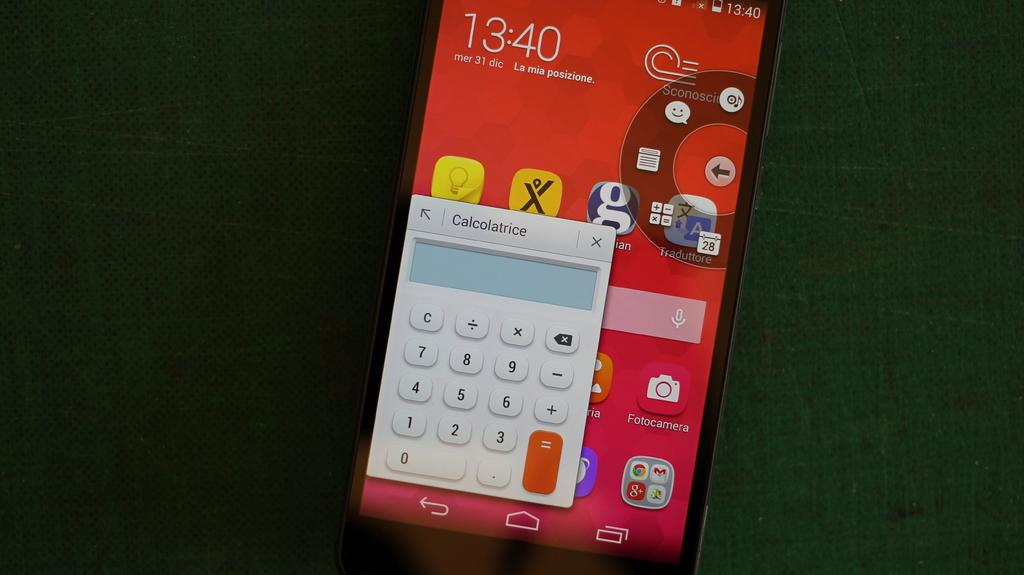<image>
Summarize the visual content of the image. A phone screen with the calculator open and clock showing 13:40 